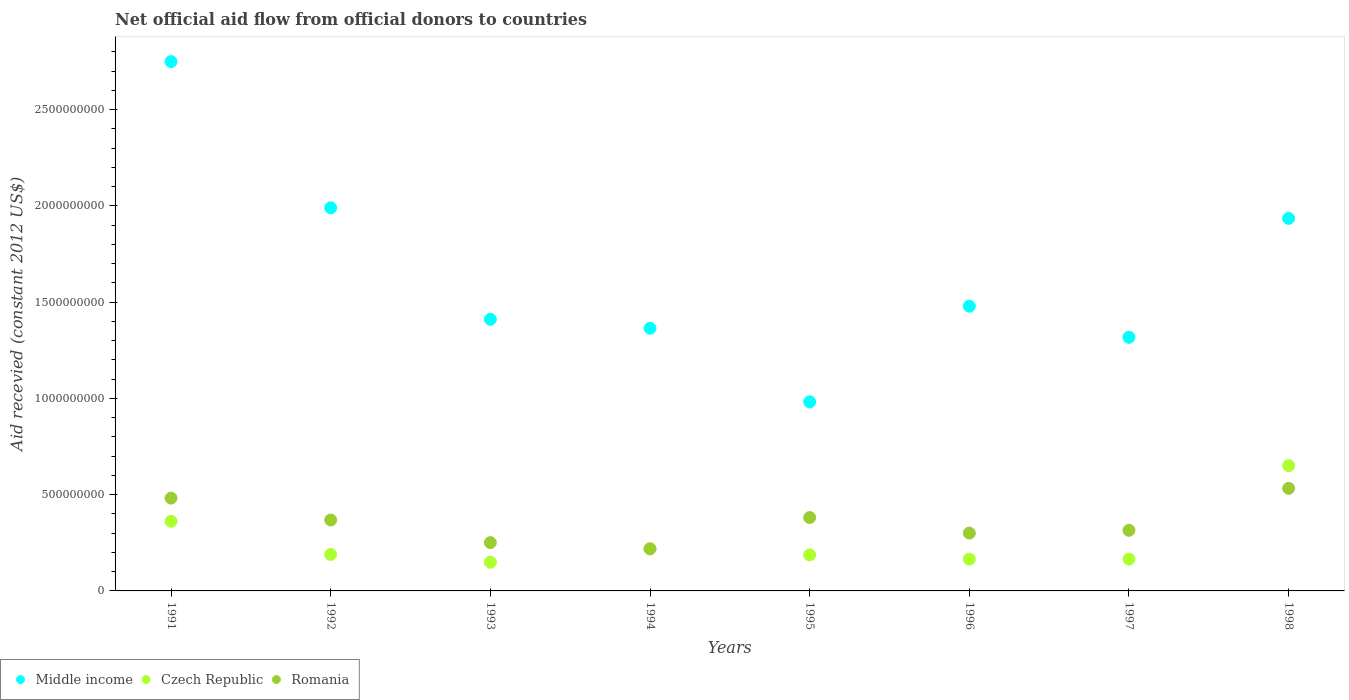How many different coloured dotlines are there?
Provide a short and direct response. 3. What is the total aid received in Czech Republic in 1995?
Provide a succinct answer. 1.87e+08. Across all years, what is the maximum total aid received in Czech Republic?
Provide a short and direct response. 6.50e+08. Across all years, what is the minimum total aid received in Middle income?
Keep it short and to the point. 9.82e+08. What is the total total aid received in Middle income in the graph?
Ensure brevity in your answer.  1.32e+1. What is the difference between the total aid received in Czech Republic in 1991 and that in 1995?
Give a very brief answer. 1.75e+08. What is the difference between the total aid received in Middle income in 1994 and the total aid received in Czech Republic in 1997?
Your answer should be compact. 1.20e+09. What is the average total aid received in Middle income per year?
Make the answer very short. 1.65e+09. In the year 1995, what is the difference between the total aid received in Czech Republic and total aid received in Romania?
Ensure brevity in your answer.  -1.94e+08. In how many years, is the total aid received in Romania greater than 2200000000 US$?
Keep it short and to the point. 0. What is the ratio of the total aid received in Middle income in 1992 to that in 1997?
Make the answer very short. 1.51. Is the difference between the total aid received in Czech Republic in 1994 and 1995 greater than the difference between the total aid received in Romania in 1994 and 1995?
Offer a terse response. Yes. What is the difference between the highest and the second highest total aid received in Romania?
Your answer should be very brief. 5.06e+07. What is the difference between the highest and the lowest total aid received in Middle income?
Offer a very short reply. 1.77e+09. In how many years, is the total aid received in Czech Republic greater than the average total aid received in Czech Republic taken over all years?
Make the answer very short. 2. Is the total aid received in Middle income strictly greater than the total aid received in Romania over the years?
Ensure brevity in your answer.  Yes. Is the total aid received in Czech Republic strictly less than the total aid received in Middle income over the years?
Offer a very short reply. Yes. How many dotlines are there?
Ensure brevity in your answer.  3. How many years are there in the graph?
Make the answer very short. 8. What is the difference between two consecutive major ticks on the Y-axis?
Your answer should be compact. 5.00e+08. Are the values on the major ticks of Y-axis written in scientific E-notation?
Provide a short and direct response. No. Does the graph contain any zero values?
Provide a short and direct response. No. Does the graph contain grids?
Your response must be concise. No. Where does the legend appear in the graph?
Give a very brief answer. Bottom left. How many legend labels are there?
Your answer should be very brief. 3. What is the title of the graph?
Provide a short and direct response. Net official aid flow from official donors to countries. What is the label or title of the X-axis?
Your response must be concise. Years. What is the label or title of the Y-axis?
Your response must be concise. Aid recevied (constant 2012 US$). What is the Aid recevied (constant 2012 US$) in Middle income in 1991?
Your response must be concise. 2.75e+09. What is the Aid recevied (constant 2012 US$) of Czech Republic in 1991?
Provide a short and direct response. 3.62e+08. What is the Aid recevied (constant 2012 US$) of Romania in 1991?
Ensure brevity in your answer.  4.82e+08. What is the Aid recevied (constant 2012 US$) in Middle income in 1992?
Make the answer very short. 1.99e+09. What is the Aid recevied (constant 2012 US$) in Czech Republic in 1992?
Give a very brief answer. 1.89e+08. What is the Aid recevied (constant 2012 US$) of Romania in 1992?
Your answer should be compact. 3.68e+08. What is the Aid recevied (constant 2012 US$) of Middle income in 1993?
Your answer should be compact. 1.41e+09. What is the Aid recevied (constant 2012 US$) in Czech Republic in 1993?
Keep it short and to the point. 1.49e+08. What is the Aid recevied (constant 2012 US$) of Romania in 1993?
Provide a succinct answer. 2.51e+08. What is the Aid recevied (constant 2012 US$) in Middle income in 1994?
Provide a short and direct response. 1.36e+09. What is the Aid recevied (constant 2012 US$) of Czech Republic in 1994?
Provide a succinct answer. 2.19e+08. What is the Aid recevied (constant 2012 US$) in Romania in 1994?
Give a very brief answer. 2.19e+08. What is the Aid recevied (constant 2012 US$) of Middle income in 1995?
Your answer should be compact. 9.82e+08. What is the Aid recevied (constant 2012 US$) of Czech Republic in 1995?
Offer a very short reply. 1.87e+08. What is the Aid recevied (constant 2012 US$) in Romania in 1995?
Offer a terse response. 3.81e+08. What is the Aid recevied (constant 2012 US$) of Middle income in 1996?
Provide a short and direct response. 1.48e+09. What is the Aid recevied (constant 2012 US$) in Czech Republic in 1996?
Give a very brief answer. 1.65e+08. What is the Aid recevied (constant 2012 US$) of Romania in 1996?
Give a very brief answer. 3.00e+08. What is the Aid recevied (constant 2012 US$) in Middle income in 1997?
Your answer should be very brief. 1.32e+09. What is the Aid recevied (constant 2012 US$) of Czech Republic in 1997?
Offer a very short reply. 1.65e+08. What is the Aid recevied (constant 2012 US$) in Romania in 1997?
Your answer should be compact. 3.15e+08. What is the Aid recevied (constant 2012 US$) in Middle income in 1998?
Offer a terse response. 1.93e+09. What is the Aid recevied (constant 2012 US$) of Czech Republic in 1998?
Your response must be concise. 6.50e+08. What is the Aid recevied (constant 2012 US$) of Romania in 1998?
Give a very brief answer. 5.33e+08. Across all years, what is the maximum Aid recevied (constant 2012 US$) in Middle income?
Give a very brief answer. 2.75e+09. Across all years, what is the maximum Aid recevied (constant 2012 US$) in Czech Republic?
Offer a very short reply. 6.50e+08. Across all years, what is the maximum Aid recevied (constant 2012 US$) in Romania?
Provide a succinct answer. 5.33e+08. Across all years, what is the minimum Aid recevied (constant 2012 US$) of Middle income?
Offer a terse response. 9.82e+08. Across all years, what is the minimum Aid recevied (constant 2012 US$) in Czech Republic?
Your answer should be very brief. 1.49e+08. Across all years, what is the minimum Aid recevied (constant 2012 US$) in Romania?
Make the answer very short. 2.19e+08. What is the total Aid recevied (constant 2012 US$) of Middle income in the graph?
Keep it short and to the point. 1.32e+1. What is the total Aid recevied (constant 2012 US$) of Czech Republic in the graph?
Offer a terse response. 2.09e+09. What is the total Aid recevied (constant 2012 US$) of Romania in the graph?
Make the answer very short. 2.85e+09. What is the difference between the Aid recevied (constant 2012 US$) of Middle income in 1991 and that in 1992?
Offer a very short reply. 7.59e+08. What is the difference between the Aid recevied (constant 2012 US$) in Czech Republic in 1991 and that in 1992?
Offer a very short reply. 1.72e+08. What is the difference between the Aid recevied (constant 2012 US$) in Romania in 1991 and that in 1992?
Provide a succinct answer. 1.14e+08. What is the difference between the Aid recevied (constant 2012 US$) in Middle income in 1991 and that in 1993?
Provide a succinct answer. 1.34e+09. What is the difference between the Aid recevied (constant 2012 US$) in Czech Republic in 1991 and that in 1993?
Offer a very short reply. 2.13e+08. What is the difference between the Aid recevied (constant 2012 US$) in Romania in 1991 and that in 1993?
Offer a terse response. 2.31e+08. What is the difference between the Aid recevied (constant 2012 US$) in Middle income in 1991 and that in 1994?
Keep it short and to the point. 1.39e+09. What is the difference between the Aid recevied (constant 2012 US$) of Czech Republic in 1991 and that in 1994?
Offer a terse response. 1.43e+08. What is the difference between the Aid recevied (constant 2012 US$) in Romania in 1991 and that in 1994?
Provide a succinct answer. 2.64e+08. What is the difference between the Aid recevied (constant 2012 US$) of Middle income in 1991 and that in 1995?
Your answer should be compact. 1.77e+09. What is the difference between the Aid recevied (constant 2012 US$) of Czech Republic in 1991 and that in 1995?
Offer a very short reply. 1.75e+08. What is the difference between the Aid recevied (constant 2012 US$) in Romania in 1991 and that in 1995?
Provide a succinct answer. 1.01e+08. What is the difference between the Aid recevied (constant 2012 US$) in Middle income in 1991 and that in 1996?
Offer a very short reply. 1.27e+09. What is the difference between the Aid recevied (constant 2012 US$) of Czech Republic in 1991 and that in 1996?
Your answer should be very brief. 1.96e+08. What is the difference between the Aid recevied (constant 2012 US$) of Romania in 1991 and that in 1996?
Keep it short and to the point. 1.82e+08. What is the difference between the Aid recevied (constant 2012 US$) of Middle income in 1991 and that in 1997?
Give a very brief answer. 1.43e+09. What is the difference between the Aid recevied (constant 2012 US$) in Czech Republic in 1991 and that in 1997?
Give a very brief answer. 1.97e+08. What is the difference between the Aid recevied (constant 2012 US$) in Romania in 1991 and that in 1997?
Your response must be concise. 1.67e+08. What is the difference between the Aid recevied (constant 2012 US$) of Middle income in 1991 and that in 1998?
Provide a succinct answer. 8.14e+08. What is the difference between the Aid recevied (constant 2012 US$) of Czech Republic in 1991 and that in 1998?
Offer a very short reply. -2.89e+08. What is the difference between the Aid recevied (constant 2012 US$) of Romania in 1991 and that in 1998?
Your answer should be very brief. -5.06e+07. What is the difference between the Aid recevied (constant 2012 US$) of Middle income in 1992 and that in 1993?
Provide a short and direct response. 5.79e+08. What is the difference between the Aid recevied (constant 2012 US$) in Czech Republic in 1992 and that in 1993?
Offer a very short reply. 4.06e+07. What is the difference between the Aid recevied (constant 2012 US$) of Romania in 1992 and that in 1993?
Your answer should be very brief. 1.18e+08. What is the difference between the Aid recevied (constant 2012 US$) in Middle income in 1992 and that in 1994?
Make the answer very short. 6.26e+08. What is the difference between the Aid recevied (constant 2012 US$) in Czech Republic in 1992 and that in 1994?
Keep it short and to the point. -2.92e+07. What is the difference between the Aid recevied (constant 2012 US$) of Romania in 1992 and that in 1994?
Provide a short and direct response. 1.50e+08. What is the difference between the Aid recevied (constant 2012 US$) in Middle income in 1992 and that in 1995?
Provide a succinct answer. 1.01e+09. What is the difference between the Aid recevied (constant 2012 US$) in Czech Republic in 1992 and that in 1995?
Your answer should be compact. 2.42e+06. What is the difference between the Aid recevied (constant 2012 US$) of Romania in 1992 and that in 1995?
Your response must be concise. -1.27e+07. What is the difference between the Aid recevied (constant 2012 US$) of Middle income in 1992 and that in 1996?
Ensure brevity in your answer.  5.11e+08. What is the difference between the Aid recevied (constant 2012 US$) in Czech Republic in 1992 and that in 1996?
Ensure brevity in your answer.  2.42e+07. What is the difference between the Aid recevied (constant 2012 US$) in Romania in 1992 and that in 1996?
Ensure brevity in your answer.  6.80e+07. What is the difference between the Aid recevied (constant 2012 US$) in Middle income in 1992 and that in 1997?
Keep it short and to the point. 6.73e+08. What is the difference between the Aid recevied (constant 2012 US$) in Czech Republic in 1992 and that in 1997?
Your response must be concise. 2.43e+07. What is the difference between the Aid recevied (constant 2012 US$) in Romania in 1992 and that in 1997?
Keep it short and to the point. 5.36e+07. What is the difference between the Aid recevied (constant 2012 US$) in Middle income in 1992 and that in 1998?
Give a very brief answer. 5.51e+07. What is the difference between the Aid recevied (constant 2012 US$) in Czech Republic in 1992 and that in 1998?
Offer a very short reply. -4.61e+08. What is the difference between the Aid recevied (constant 2012 US$) in Romania in 1992 and that in 1998?
Provide a short and direct response. -1.64e+08. What is the difference between the Aid recevied (constant 2012 US$) of Middle income in 1993 and that in 1994?
Provide a succinct answer. 4.66e+07. What is the difference between the Aid recevied (constant 2012 US$) of Czech Republic in 1993 and that in 1994?
Your answer should be very brief. -6.97e+07. What is the difference between the Aid recevied (constant 2012 US$) in Romania in 1993 and that in 1994?
Your response must be concise. 3.24e+07. What is the difference between the Aid recevied (constant 2012 US$) in Middle income in 1993 and that in 1995?
Provide a short and direct response. 4.29e+08. What is the difference between the Aid recevied (constant 2012 US$) in Czech Republic in 1993 and that in 1995?
Offer a very short reply. -3.82e+07. What is the difference between the Aid recevied (constant 2012 US$) in Romania in 1993 and that in 1995?
Provide a short and direct response. -1.30e+08. What is the difference between the Aid recevied (constant 2012 US$) in Middle income in 1993 and that in 1996?
Ensure brevity in your answer.  -6.84e+07. What is the difference between the Aid recevied (constant 2012 US$) in Czech Republic in 1993 and that in 1996?
Your answer should be very brief. -1.64e+07. What is the difference between the Aid recevied (constant 2012 US$) in Romania in 1993 and that in 1996?
Give a very brief answer. -4.95e+07. What is the difference between the Aid recevied (constant 2012 US$) in Middle income in 1993 and that in 1997?
Your answer should be very brief. 9.34e+07. What is the difference between the Aid recevied (constant 2012 US$) in Czech Republic in 1993 and that in 1997?
Offer a very short reply. -1.63e+07. What is the difference between the Aid recevied (constant 2012 US$) in Romania in 1993 and that in 1997?
Offer a terse response. -6.39e+07. What is the difference between the Aid recevied (constant 2012 US$) in Middle income in 1993 and that in 1998?
Your response must be concise. -5.24e+08. What is the difference between the Aid recevied (constant 2012 US$) in Czech Republic in 1993 and that in 1998?
Give a very brief answer. -5.02e+08. What is the difference between the Aid recevied (constant 2012 US$) of Romania in 1993 and that in 1998?
Your answer should be compact. -2.82e+08. What is the difference between the Aid recevied (constant 2012 US$) of Middle income in 1994 and that in 1995?
Ensure brevity in your answer.  3.82e+08. What is the difference between the Aid recevied (constant 2012 US$) of Czech Republic in 1994 and that in 1995?
Keep it short and to the point. 3.16e+07. What is the difference between the Aid recevied (constant 2012 US$) of Romania in 1994 and that in 1995?
Offer a terse response. -1.63e+08. What is the difference between the Aid recevied (constant 2012 US$) in Middle income in 1994 and that in 1996?
Offer a terse response. -1.15e+08. What is the difference between the Aid recevied (constant 2012 US$) of Czech Republic in 1994 and that in 1996?
Offer a terse response. 5.34e+07. What is the difference between the Aid recevied (constant 2012 US$) of Romania in 1994 and that in 1996?
Make the answer very short. -8.19e+07. What is the difference between the Aid recevied (constant 2012 US$) in Middle income in 1994 and that in 1997?
Your response must be concise. 4.68e+07. What is the difference between the Aid recevied (constant 2012 US$) of Czech Republic in 1994 and that in 1997?
Your answer should be very brief. 5.34e+07. What is the difference between the Aid recevied (constant 2012 US$) in Romania in 1994 and that in 1997?
Ensure brevity in your answer.  -9.63e+07. What is the difference between the Aid recevied (constant 2012 US$) of Middle income in 1994 and that in 1998?
Offer a terse response. -5.71e+08. What is the difference between the Aid recevied (constant 2012 US$) in Czech Republic in 1994 and that in 1998?
Offer a terse response. -4.32e+08. What is the difference between the Aid recevied (constant 2012 US$) of Romania in 1994 and that in 1998?
Your answer should be compact. -3.14e+08. What is the difference between the Aid recevied (constant 2012 US$) in Middle income in 1995 and that in 1996?
Offer a very short reply. -4.97e+08. What is the difference between the Aid recevied (constant 2012 US$) in Czech Republic in 1995 and that in 1996?
Your answer should be very brief. 2.18e+07. What is the difference between the Aid recevied (constant 2012 US$) in Romania in 1995 and that in 1996?
Offer a very short reply. 8.07e+07. What is the difference between the Aid recevied (constant 2012 US$) in Middle income in 1995 and that in 1997?
Your answer should be very brief. -3.35e+08. What is the difference between the Aid recevied (constant 2012 US$) in Czech Republic in 1995 and that in 1997?
Your response must be concise. 2.19e+07. What is the difference between the Aid recevied (constant 2012 US$) in Romania in 1995 and that in 1997?
Offer a very short reply. 6.63e+07. What is the difference between the Aid recevied (constant 2012 US$) of Middle income in 1995 and that in 1998?
Offer a terse response. -9.53e+08. What is the difference between the Aid recevied (constant 2012 US$) of Czech Republic in 1995 and that in 1998?
Your answer should be compact. -4.63e+08. What is the difference between the Aid recevied (constant 2012 US$) in Romania in 1995 and that in 1998?
Make the answer very short. -1.52e+08. What is the difference between the Aid recevied (constant 2012 US$) in Middle income in 1996 and that in 1997?
Your response must be concise. 1.62e+08. What is the difference between the Aid recevied (constant 2012 US$) of Czech Republic in 1996 and that in 1997?
Offer a terse response. 1.00e+05. What is the difference between the Aid recevied (constant 2012 US$) of Romania in 1996 and that in 1997?
Ensure brevity in your answer.  -1.44e+07. What is the difference between the Aid recevied (constant 2012 US$) of Middle income in 1996 and that in 1998?
Your answer should be very brief. -4.56e+08. What is the difference between the Aid recevied (constant 2012 US$) in Czech Republic in 1996 and that in 1998?
Your answer should be very brief. -4.85e+08. What is the difference between the Aid recevied (constant 2012 US$) in Romania in 1996 and that in 1998?
Provide a short and direct response. -2.32e+08. What is the difference between the Aid recevied (constant 2012 US$) of Middle income in 1997 and that in 1998?
Give a very brief answer. -6.18e+08. What is the difference between the Aid recevied (constant 2012 US$) in Czech Republic in 1997 and that in 1998?
Offer a very short reply. -4.85e+08. What is the difference between the Aid recevied (constant 2012 US$) in Romania in 1997 and that in 1998?
Provide a succinct answer. -2.18e+08. What is the difference between the Aid recevied (constant 2012 US$) of Middle income in 1991 and the Aid recevied (constant 2012 US$) of Czech Republic in 1992?
Provide a succinct answer. 2.56e+09. What is the difference between the Aid recevied (constant 2012 US$) of Middle income in 1991 and the Aid recevied (constant 2012 US$) of Romania in 1992?
Your answer should be compact. 2.38e+09. What is the difference between the Aid recevied (constant 2012 US$) of Czech Republic in 1991 and the Aid recevied (constant 2012 US$) of Romania in 1992?
Your answer should be very brief. -6.78e+06. What is the difference between the Aid recevied (constant 2012 US$) in Middle income in 1991 and the Aid recevied (constant 2012 US$) in Czech Republic in 1993?
Offer a very short reply. 2.60e+09. What is the difference between the Aid recevied (constant 2012 US$) of Middle income in 1991 and the Aid recevied (constant 2012 US$) of Romania in 1993?
Provide a short and direct response. 2.50e+09. What is the difference between the Aid recevied (constant 2012 US$) in Czech Republic in 1991 and the Aid recevied (constant 2012 US$) in Romania in 1993?
Your answer should be compact. 1.11e+08. What is the difference between the Aid recevied (constant 2012 US$) of Middle income in 1991 and the Aid recevied (constant 2012 US$) of Czech Republic in 1994?
Provide a succinct answer. 2.53e+09. What is the difference between the Aid recevied (constant 2012 US$) of Middle income in 1991 and the Aid recevied (constant 2012 US$) of Romania in 1994?
Ensure brevity in your answer.  2.53e+09. What is the difference between the Aid recevied (constant 2012 US$) of Czech Republic in 1991 and the Aid recevied (constant 2012 US$) of Romania in 1994?
Offer a terse response. 1.43e+08. What is the difference between the Aid recevied (constant 2012 US$) of Middle income in 1991 and the Aid recevied (constant 2012 US$) of Czech Republic in 1995?
Your response must be concise. 2.56e+09. What is the difference between the Aid recevied (constant 2012 US$) in Middle income in 1991 and the Aid recevied (constant 2012 US$) in Romania in 1995?
Offer a very short reply. 2.37e+09. What is the difference between the Aid recevied (constant 2012 US$) of Czech Republic in 1991 and the Aid recevied (constant 2012 US$) of Romania in 1995?
Provide a short and direct response. -1.95e+07. What is the difference between the Aid recevied (constant 2012 US$) of Middle income in 1991 and the Aid recevied (constant 2012 US$) of Czech Republic in 1996?
Give a very brief answer. 2.58e+09. What is the difference between the Aid recevied (constant 2012 US$) of Middle income in 1991 and the Aid recevied (constant 2012 US$) of Romania in 1996?
Offer a terse response. 2.45e+09. What is the difference between the Aid recevied (constant 2012 US$) of Czech Republic in 1991 and the Aid recevied (constant 2012 US$) of Romania in 1996?
Keep it short and to the point. 6.12e+07. What is the difference between the Aid recevied (constant 2012 US$) in Middle income in 1991 and the Aid recevied (constant 2012 US$) in Czech Republic in 1997?
Provide a short and direct response. 2.58e+09. What is the difference between the Aid recevied (constant 2012 US$) in Middle income in 1991 and the Aid recevied (constant 2012 US$) in Romania in 1997?
Ensure brevity in your answer.  2.43e+09. What is the difference between the Aid recevied (constant 2012 US$) in Czech Republic in 1991 and the Aid recevied (constant 2012 US$) in Romania in 1997?
Provide a succinct answer. 4.68e+07. What is the difference between the Aid recevied (constant 2012 US$) in Middle income in 1991 and the Aid recevied (constant 2012 US$) in Czech Republic in 1998?
Your answer should be compact. 2.10e+09. What is the difference between the Aid recevied (constant 2012 US$) in Middle income in 1991 and the Aid recevied (constant 2012 US$) in Romania in 1998?
Your response must be concise. 2.22e+09. What is the difference between the Aid recevied (constant 2012 US$) in Czech Republic in 1991 and the Aid recevied (constant 2012 US$) in Romania in 1998?
Ensure brevity in your answer.  -1.71e+08. What is the difference between the Aid recevied (constant 2012 US$) of Middle income in 1992 and the Aid recevied (constant 2012 US$) of Czech Republic in 1993?
Offer a very short reply. 1.84e+09. What is the difference between the Aid recevied (constant 2012 US$) of Middle income in 1992 and the Aid recevied (constant 2012 US$) of Romania in 1993?
Keep it short and to the point. 1.74e+09. What is the difference between the Aid recevied (constant 2012 US$) of Czech Republic in 1992 and the Aid recevied (constant 2012 US$) of Romania in 1993?
Give a very brief answer. -6.15e+07. What is the difference between the Aid recevied (constant 2012 US$) of Middle income in 1992 and the Aid recevied (constant 2012 US$) of Czech Republic in 1994?
Keep it short and to the point. 1.77e+09. What is the difference between the Aid recevied (constant 2012 US$) of Middle income in 1992 and the Aid recevied (constant 2012 US$) of Romania in 1994?
Ensure brevity in your answer.  1.77e+09. What is the difference between the Aid recevied (constant 2012 US$) of Czech Republic in 1992 and the Aid recevied (constant 2012 US$) of Romania in 1994?
Your answer should be very brief. -2.92e+07. What is the difference between the Aid recevied (constant 2012 US$) of Middle income in 1992 and the Aid recevied (constant 2012 US$) of Czech Republic in 1995?
Your answer should be very brief. 1.80e+09. What is the difference between the Aid recevied (constant 2012 US$) in Middle income in 1992 and the Aid recevied (constant 2012 US$) in Romania in 1995?
Provide a succinct answer. 1.61e+09. What is the difference between the Aid recevied (constant 2012 US$) of Czech Republic in 1992 and the Aid recevied (constant 2012 US$) of Romania in 1995?
Your answer should be very brief. -1.92e+08. What is the difference between the Aid recevied (constant 2012 US$) in Middle income in 1992 and the Aid recevied (constant 2012 US$) in Czech Republic in 1996?
Provide a succinct answer. 1.82e+09. What is the difference between the Aid recevied (constant 2012 US$) in Middle income in 1992 and the Aid recevied (constant 2012 US$) in Romania in 1996?
Your answer should be compact. 1.69e+09. What is the difference between the Aid recevied (constant 2012 US$) of Czech Republic in 1992 and the Aid recevied (constant 2012 US$) of Romania in 1996?
Your answer should be compact. -1.11e+08. What is the difference between the Aid recevied (constant 2012 US$) of Middle income in 1992 and the Aid recevied (constant 2012 US$) of Czech Republic in 1997?
Your response must be concise. 1.82e+09. What is the difference between the Aid recevied (constant 2012 US$) of Middle income in 1992 and the Aid recevied (constant 2012 US$) of Romania in 1997?
Offer a very short reply. 1.68e+09. What is the difference between the Aid recevied (constant 2012 US$) of Czech Republic in 1992 and the Aid recevied (constant 2012 US$) of Romania in 1997?
Your answer should be compact. -1.25e+08. What is the difference between the Aid recevied (constant 2012 US$) of Middle income in 1992 and the Aid recevied (constant 2012 US$) of Czech Republic in 1998?
Keep it short and to the point. 1.34e+09. What is the difference between the Aid recevied (constant 2012 US$) of Middle income in 1992 and the Aid recevied (constant 2012 US$) of Romania in 1998?
Your answer should be compact. 1.46e+09. What is the difference between the Aid recevied (constant 2012 US$) in Czech Republic in 1992 and the Aid recevied (constant 2012 US$) in Romania in 1998?
Ensure brevity in your answer.  -3.43e+08. What is the difference between the Aid recevied (constant 2012 US$) of Middle income in 1993 and the Aid recevied (constant 2012 US$) of Czech Republic in 1994?
Offer a very short reply. 1.19e+09. What is the difference between the Aid recevied (constant 2012 US$) in Middle income in 1993 and the Aid recevied (constant 2012 US$) in Romania in 1994?
Make the answer very short. 1.19e+09. What is the difference between the Aid recevied (constant 2012 US$) of Czech Republic in 1993 and the Aid recevied (constant 2012 US$) of Romania in 1994?
Offer a terse response. -6.97e+07. What is the difference between the Aid recevied (constant 2012 US$) in Middle income in 1993 and the Aid recevied (constant 2012 US$) in Czech Republic in 1995?
Provide a short and direct response. 1.22e+09. What is the difference between the Aid recevied (constant 2012 US$) of Middle income in 1993 and the Aid recevied (constant 2012 US$) of Romania in 1995?
Ensure brevity in your answer.  1.03e+09. What is the difference between the Aid recevied (constant 2012 US$) of Czech Republic in 1993 and the Aid recevied (constant 2012 US$) of Romania in 1995?
Provide a succinct answer. -2.32e+08. What is the difference between the Aid recevied (constant 2012 US$) in Middle income in 1993 and the Aid recevied (constant 2012 US$) in Czech Republic in 1996?
Your response must be concise. 1.25e+09. What is the difference between the Aid recevied (constant 2012 US$) in Middle income in 1993 and the Aid recevied (constant 2012 US$) in Romania in 1996?
Ensure brevity in your answer.  1.11e+09. What is the difference between the Aid recevied (constant 2012 US$) of Czech Republic in 1993 and the Aid recevied (constant 2012 US$) of Romania in 1996?
Ensure brevity in your answer.  -1.52e+08. What is the difference between the Aid recevied (constant 2012 US$) of Middle income in 1993 and the Aid recevied (constant 2012 US$) of Czech Republic in 1997?
Your answer should be compact. 1.25e+09. What is the difference between the Aid recevied (constant 2012 US$) in Middle income in 1993 and the Aid recevied (constant 2012 US$) in Romania in 1997?
Keep it short and to the point. 1.10e+09. What is the difference between the Aid recevied (constant 2012 US$) of Czech Republic in 1993 and the Aid recevied (constant 2012 US$) of Romania in 1997?
Give a very brief answer. -1.66e+08. What is the difference between the Aid recevied (constant 2012 US$) in Middle income in 1993 and the Aid recevied (constant 2012 US$) in Czech Republic in 1998?
Your answer should be very brief. 7.60e+08. What is the difference between the Aid recevied (constant 2012 US$) in Middle income in 1993 and the Aid recevied (constant 2012 US$) in Romania in 1998?
Keep it short and to the point. 8.78e+08. What is the difference between the Aid recevied (constant 2012 US$) of Czech Republic in 1993 and the Aid recevied (constant 2012 US$) of Romania in 1998?
Ensure brevity in your answer.  -3.84e+08. What is the difference between the Aid recevied (constant 2012 US$) of Middle income in 1994 and the Aid recevied (constant 2012 US$) of Czech Republic in 1995?
Offer a terse response. 1.18e+09. What is the difference between the Aid recevied (constant 2012 US$) in Middle income in 1994 and the Aid recevied (constant 2012 US$) in Romania in 1995?
Your answer should be compact. 9.83e+08. What is the difference between the Aid recevied (constant 2012 US$) in Czech Republic in 1994 and the Aid recevied (constant 2012 US$) in Romania in 1995?
Your answer should be very brief. -1.63e+08. What is the difference between the Aid recevied (constant 2012 US$) in Middle income in 1994 and the Aid recevied (constant 2012 US$) in Czech Republic in 1996?
Make the answer very short. 1.20e+09. What is the difference between the Aid recevied (constant 2012 US$) of Middle income in 1994 and the Aid recevied (constant 2012 US$) of Romania in 1996?
Your answer should be very brief. 1.06e+09. What is the difference between the Aid recevied (constant 2012 US$) in Czech Republic in 1994 and the Aid recevied (constant 2012 US$) in Romania in 1996?
Provide a succinct answer. -8.19e+07. What is the difference between the Aid recevied (constant 2012 US$) of Middle income in 1994 and the Aid recevied (constant 2012 US$) of Czech Republic in 1997?
Offer a terse response. 1.20e+09. What is the difference between the Aid recevied (constant 2012 US$) in Middle income in 1994 and the Aid recevied (constant 2012 US$) in Romania in 1997?
Offer a very short reply. 1.05e+09. What is the difference between the Aid recevied (constant 2012 US$) in Czech Republic in 1994 and the Aid recevied (constant 2012 US$) in Romania in 1997?
Your response must be concise. -9.63e+07. What is the difference between the Aid recevied (constant 2012 US$) in Middle income in 1994 and the Aid recevied (constant 2012 US$) in Czech Republic in 1998?
Offer a very short reply. 7.14e+08. What is the difference between the Aid recevied (constant 2012 US$) in Middle income in 1994 and the Aid recevied (constant 2012 US$) in Romania in 1998?
Give a very brief answer. 8.31e+08. What is the difference between the Aid recevied (constant 2012 US$) of Czech Republic in 1994 and the Aid recevied (constant 2012 US$) of Romania in 1998?
Your answer should be compact. -3.14e+08. What is the difference between the Aid recevied (constant 2012 US$) of Middle income in 1995 and the Aid recevied (constant 2012 US$) of Czech Republic in 1996?
Offer a terse response. 8.17e+08. What is the difference between the Aid recevied (constant 2012 US$) in Middle income in 1995 and the Aid recevied (constant 2012 US$) in Romania in 1996?
Your answer should be compact. 6.81e+08. What is the difference between the Aid recevied (constant 2012 US$) of Czech Republic in 1995 and the Aid recevied (constant 2012 US$) of Romania in 1996?
Your answer should be compact. -1.13e+08. What is the difference between the Aid recevied (constant 2012 US$) of Middle income in 1995 and the Aid recevied (constant 2012 US$) of Czech Republic in 1997?
Offer a terse response. 8.17e+08. What is the difference between the Aid recevied (constant 2012 US$) of Middle income in 1995 and the Aid recevied (constant 2012 US$) of Romania in 1997?
Ensure brevity in your answer.  6.67e+08. What is the difference between the Aid recevied (constant 2012 US$) of Czech Republic in 1995 and the Aid recevied (constant 2012 US$) of Romania in 1997?
Offer a terse response. -1.28e+08. What is the difference between the Aid recevied (constant 2012 US$) in Middle income in 1995 and the Aid recevied (constant 2012 US$) in Czech Republic in 1998?
Make the answer very short. 3.32e+08. What is the difference between the Aid recevied (constant 2012 US$) in Middle income in 1995 and the Aid recevied (constant 2012 US$) in Romania in 1998?
Give a very brief answer. 4.49e+08. What is the difference between the Aid recevied (constant 2012 US$) of Czech Republic in 1995 and the Aid recevied (constant 2012 US$) of Romania in 1998?
Give a very brief answer. -3.46e+08. What is the difference between the Aid recevied (constant 2012 US$) in Middle income in 1996 and the Aid recevied (constant 2012 US$) in Czech Republic in 1997?
Make the answer very short. 1.31e+09. What is the difference between the Aid recevied (constant 2012 US$) of Middle income in 1996 and the Aid recevied (constant 2012 US$) of Romania in 1997?
Your response must be concise. 1.16e+09. What is the difference between the Aid recevied (constant 2012 US$) in Czech Republic in 1996 and the Aid recevied (constant 2012 US$) in Romania in 1997?
Give a very brief answer. -1.50e+08. What is the difference between the Aid recevied (constant 2012 US$) in Middle income in 1996 and the Aid recevied (constant 2012 US$) in Czech Republic in 1998?
Give a very brief answer. 8.28e+08. What is the difference between the Aid recevied (constant 2012 US$) in Middle income in 1996 and the Aid recevied (constant 2012 US$) in Romania in 1998?
Offer a very short reply. 9.46e+08. What is the difference between the Aid recevied (constant 2012 US$) of Czech Republic in 1996 and the Aid recevied (constant 2012 US$) of Romania in 1998?
Offer a very short reply. -3.67e+08. What is the difference between the Aid recevied (constant 2012 US$) in Middle income in 1997 and the Aid recevied (constant 2012 US$) in Czech Republic in 1998?
Provide a short and direct response. 6.67e+08. What is the difference between the Aid recevied (constant 2012 US$) of Middle income in 1997 and the Aid recevied (constant 2012 US$) of Romania in 1998?
Your answer should be very brief. 7.84e+08. What is the difference between the Aid recevied (constant 2012 US$) of Czech Republic in 1997 and the Aid recevied (constant 2012 US$) of Romania in 1998?
Your answer should be compact. -3.68e+08. What is the average Aid recevied (constant 2012 US$) in Middle income per year?
Ensure brevity in your answer.  1.65e+09. What is the average Aid recevied (constant 2012 US$) in Czech Republic per year?
Make the answer very short. 2.61e+08. What is the average Aid recevied (constant 2012 US$) in Romania per year?
Ensure brevity in your answer.  3.56e+08. In the year 1991, what is the difference between the Aid recevied (constant 2012 US$) in Middle income and Aid recevied (constant 2012 US$) in Czech Republic?
Provide a short and direct response. 2.39e+09. In the year 1991, what is the difference between the Aid recevied (constant 2012 US$) in Middle income and Aid recevied (constant 2012 US$) in Romania?
Your answer should be compact. 2.27e+09. In the year 1991, what is the difference between the Aid recevied (constant 2012 US$) in Czech Republic and Aid recevied (constant 2012 US$) in Romania?
Offer a terse response. -1.20e+08. In the year 1992, what is the difference between the Aid recevied (constant 2012 US$) of Middle income and Aid recevied (constant 2012 US$) of Czech Republic?
Offer a terse response. 1.80e+09. In the year 1992, what is the difference between the Aid recevied (constant 2012 US$) in Middle income and Aid recevied (constant 2012 US$) in Romania?
Offer a terse response. 1.62e+09. In the year 1992, what is the difference between the Aid recevied (constant 2012 US$) in Czech Republic and Aid recevied (constant 2012 US$) in Romania?
Make the answer very short. -1.79e+08. In the year 1993, what is the difference between the Aid recevied (constant 2012 US$) of Middle income and Aid recevied (constant 2012 US$) of Czech Republic?
Your answer should be very brief. 1.26e+09. In the year 1993, what is the difference between the Aid recevied (constant 2012 US$) in Middle income and Aid recevied (constant 2012 US$) in Romania?
Ensure brevity in your answer.  1.16e+09. In the year 1993, what is the difference between the Aid recevied (constant 2012 US$) in Czech Republic and Aid recevied (constant 2012 US$) in Romania?
Ensure brevity in your answer.  -1.02e+08. In the year 1994, what is the difference between the Aid recevied (constant 2012 US$) of Middle income and Aid recevied (constant 2012 US$) of Czech Republic?
Provide a short and direct response. 1.15e+09. In the year 1994, what is the difference between the Aid recevied (constant 2012 US$) of Middle income and Aid recevied (constant 2012 US$) of Romania?
Keep it short and to the point. 1.15e+09. In the year 1995, what is the difference between the Aid recevied (constant 2012 US$) of Middle income and Aid recevied (constant 2012 US$) of Czech Republic?
Provide a succinct answer. 7.95e+08. In the year 1995, what is the difference between the Aid recevied (constant 2012 US$) of Middle income and Aid recevied (constant 2012 US$) of Romania?
Keep it short and to the point. 6.01e+08. In the year 1995, what is the difference between the Aid recevied (constant 2012 US$) of Czech Republic and Aid recevied (constant 2012 US$) of Romania?
Your answer should be very brief. -1.94e+08. In the year 1996, what is the difference between the Aid recevied (constant 2012 US$) in Middle income and Aid recevied (constant 2012 US$) in Czech Republic?
Your answer should be very brief. 1.31e+09. In the year 1996, what is the difference between the Aid recevied (constant 2012 US$) in Middle income and Aid recevied (constant 2012 US$) in Romania?
Make the answer very short. 1.18e+09. In the year 1996, what is the difference between the Aid recevied (constant 2012 US$) in Czech Republic and Aid recevied (constant 2012 US$) in Romania?
Keep it short and to the point. -1.35e+08. In the year 1997, what is the difference between the Aid recevied (constant 2012 US$) of Middle income and Aid recevied (constant 2012 US$) of Czech Republic?
Provide a succinct answer. 1.15e+09. In the year 1997, what is the difference between the Aid recevied (constant 2012 US$) of Middle income and Aid recevied (constant 2012 US$) of Romania?
Offer a terse response. 1.00e+09. In the year 1997, what is the difference between the Aid recevied (constant 2012 US$) of Czech Republic and Aid recevied (constant 2012 US$) of Romania?
Provide a succinct answer. -1.50e+08. In the year 1998, what is the difference between the Aid recevied (constant 2012 US$) of Middle income and Aid recevied (constant 2012 US$) of Czech Republic?
Give a very brief answer. 1.28e+09. In the year 1998, what is the difference between the Aid recevied (constant 2012 US$) in Middle income and Aid recevied (constant 2012 US$) in Romania?
Provide a succinct answer. 1.40e+09. In the year 1998, what is the difference between the Aid recevied (constant 2012 US$) of Czech Republic and Aid recevied (constant 2012 US$) of Romania?
Offer a very short reply. 1.18e+08. What is the ratio of the Aid recevied (constant 2012 US$) in Middle income in 1991 to that in 1992?
Your answer should be compact. 1.38. What is the ratio of the Aid recevied (constant 2012 US$) in Czech Republic in 1991 to that in 1992?
Provide a short and direct response. 1.91. What is the ratio of the Aid recevied (constant 2012 US$) of Romania in 1991 to that in 1992?
Give a very brief answer. 1.31. What is the ratio of the Aid recevied (constant 2012 US$) of Middle income in 1991 to that in 1993?
Your answer should be compact. 1.95. What is the ratio of the Aid recevied (constant 2012 US$) of Czech Republic in 1991 to that in 1993?
Provide a succinct answer. 2.43. What is the ratio of the Aid recevied (constant 2012 US$) of Romania in 1991 to that in 1993?
Provide a short and direct response. 1.92. What is the ratio of the Aid recevied (constant 2012 US$) in Middle income in 1991 to that in 1994?
Offer a terse response. 2.02. What is the ratio of the Aid recevied (constant 2012 US$) of Czech Republic in 1991 to that in 1994?
Offer a terse response. 1.65. What is the ratio of the Aid recevied (constant 2012 US$) of Romania in 1991 to that in 1994?
Offer a very short reply. 2.21. What is the ratio of the Aid recevied (constant 2012 US$) in Middle income in 1991 to that in 1995?
Provide a short and direct response. 2.8. What is the ratio of the Aid recevied (constant 2012 US$) of Czech Republic in 1991 to that in 1995?
Offer a very short reply. 1.93. What is the ratio of the Aid recevied (constant 2012 US$) of Romania in 1991 to that in 1995?
Offer a very short reply. 1.26. What is the ratio of the Aid recevied (constant 2012 US$) in Middle income in 1991 to that in 1996?
Make the answer very short. 1.86. What is the ratio of the Aid recevied (constant 2012 US$) of Czech Republic in 1991 to that in 1996?
Your answer should be very brief. 2.19. What is the ratio of the Aid recevied (constant 2012 US$) of Romania in 1991 to that in 1996?
Your answer should be compact. 1.6. What is the ratio of the Aid recevied (constant 2012 US$) of Middle income in 1991 to that in 1997?
Your answer should be very brief. 2.09. What is the ratio of the Aid recevied (constant 2012 US$) in Czech Republic in 1991 to that in 1997?
Make the answer very short. 2.19. What is the ratio of the Aid recevied (constant 2012 US$) in Romania in 1991 to that in 1997?
Give a very brief answer. 1.53. What is the ratio of the Aid recevied (constant 2012 US$) of Middle income in 1991 to that in 1998?
Give a very brief answer. 1.42. What is the ratio of the Aid recevied (constant 2012 US$) in Czech Republic in 1991 to that in 1998?
Provide a short and direct response. 0.56. What is the ratio of the Aid recevied (constant 2012 US$) of Romania in 1991 to that in 1998?
Your answer should be compact. 0.91. What is the ratio of the Aid recevied (constant 2012 US$) in Middle income in 1992 to that in 1993?
Provide a short and direct response. 1.41. What is the ratio of the Aid recevied (constant 2012 US$) in Czech Republic in 1992 to that in 1993?
Your answer should be compact. 1.27. What is the ratio of the Aid recevied (constant 2012 US$) in Romania in 1992 to that in 1993?
Your answer should be compact. 1.47. What is the ratio of the Aid recevied (constant 2012 US$) of Middle income in 1992 to that in 1994?
Give a very brief answer. 1.46. What is the ratio of the Aid recevied (constant 2012 US$) of Czech Republic in 1992 to that in 1994?
Make the answer very short. 0.87. What is the ratio of the Aid recevied (constant 2012 US$) of Romania in 1992 to that in 1994?
Make the answer very short. 1.69. What is the ratio of the Aid recevied (constant 2012 US$) in Middle income in 1992 to that in 1995?
Give a very brief answer. 2.03. What is the ratio of the Aid recevied (constant 2012 US$) in Czech Republic in 1992 to that in 1995?
Give a very brief answer. 1.01. What is the ratio of the Aid recevied (constant 2012 US$) of Romania in 1992 to that in 1995?
Make the answer very short. 0.97. What is the ratio of the Aid recevied (constant 2012 US$) of Middle income in 1992 to that in 1996?
Keep it short and to the point. 1.35. What is the ratio of the Aid recevied (constant 2012 US$) of Czech Republic in 1992 to that in 1996?
Offer a very short reply. 1.15. What is the ratio of the Aid recevied (constant 2012 US$) of Romania in 1992 to that in 1996?
Give a very brief answer. 1.23. What is the ratio of the Aid recevied (constant 2012 US$) in Middle income in 1992 to that in 1997?
Offer a terse response. 1.51. What is the ratio of the Aid recevied (constant 2012 US$) of Czech Republic in 1992 to that in 1997?
Ensure brevity in your answer.  1.15. What is the ratio of the Aid recevied (constant 2012 US$) in Romania in 1992 to that in 1997?
Offer a very short reply. 1.17. What is the ratio of the Aid recevied (constant 2012 US$) of Middle income in 1992 to that in 1998?
Your answer should be very brief. 1.03. What is the ratio of the Aid recevied (constant 2012 US$) of Czech Republic in 1992 to that in 1998?
Provide a short and direct response. 0.29. What is the ratio of the Aid recevied (constant 2012 US$) in Romania in 1992 to that in 1998?
Provide a short and direct response. 0.69. What is the ratio of the Aid recevied (constant 2012 US$) of Middle income in 1993 to that in 1994?
Keep it short and to the point. 1.03. What is the ratio of the Aid recevied (constant 2012 US$) in Czech Republic in 1993 to that in 1994?
Ensure brevity in your answer.  0.68. What is the ratio of the Aid recevied (constant 2012 US$) of Romania in 1993 to that in 1994?
Keep it short and to the point. 1.15. What is the ratio of the Aid recevied (constant 2012 US$) in Middle income in 1993 to that in 1995?
Provide a succinct answer. 1.44. What is the ratio of the Aid recevied (constant 2012 US$) of Czech Republic in 1993 to that in 1995?
Ensure brevity in your answer.  0.8. What is the ratio of the Aid recevied (constant 2012 US$) of Romania in 1993 to that in 1995?
Make the answer very short. 0.66. What is the ratio of the Aid recevied (constant 2012 US$) in Middle income in 1993 to that in 1996?
Give a very brief answer. 0.95. What is the ratio of the Aid recevied (constant 2012 US$) of Czech Republic in 1993 to that in 1996?
Keep it short and to the point. 0.9. What is the ratio of the Aid recevied (constant 2012 US$) in Romania in 1993 to that in 1996?
Provide a short and direct response. 0.84. What is the ratio of the Aid recevied (constant 2012 US$) of Middle income in 1993 to that in 1997?
Provide a succinct answer. 1.07. What is the ratio of the Aid recevied (constant 2012 US$) of Czech Republic in 1993 to that in 1997?
Ensure brevity in your answer.  0.9. What is the ratio of the Aid recevied (constant 2012 US$) in Romania in 1993 to that in 1997?
Make the answer very short. 0.8. What is the ratio of the Aid recevied (constant 2012 US$) in Middle income in 1993 to that in 1998?
Ensure brevity in your answer.  0.73. What is the ratio of the Aid recevied (constant 2012 US$) of Czech Republic in 1993 to that in 1998?
Offer a terse response. 0.23. What is the ratio of the Aid recevied (constant 2012 US$) in Romania in 1993 to that in 1998?
Your answer should be very brief. 0.47. What is the ratio of the Aid recevied (constant 2012 US$) in Middle income in 1994 to that in 1995?
Your answer should be compact. 1.39. What is the ratio of the Aid recevied (constant 2012 US$) of Czech Republic in 1994 to that in 1995?
Your response must be concise. 1.17. What is the ratio of the Aid recevied (constant 2012 US$) of Romania in 1994 to that in 1995?
Your answer should be very brief. 0.57. What is the ratio of the Aid recevied (constant 2012 US$) in Middle income in 1994 to that in 1996?
Make the answer very short. 0.92. What is the ratio of the Aid recevied (constant 2012 US$) of Czech Republic in 1994 to that in 1996?
Ensure brevity in your answer.  1.32. What is the ratio of the Aid recevied (constant 2012 US$) in Romania in 1994 to that in 1996?
Ensure brevity in your answer.  0.73. What is the ratio of the Aid recevied (constant 2012 US$) of Middle income in 1994 to that in 1997?
Your answer should be very brief. 1.04. What is the ratio of the Aid recevied (constant 2012 US$) in Czech Republic in 1994 to that in 1997?
Offer a terse response. 1.32. What is the ratio of the Aid recevied (constant 2012 US$) of Romania in 1994 to that in 1997?
Make the answer very short. 0.69. What is the ratio of the Aid recevied (constant 2012 US$) of Middle income in 1994 to that in 1998?
Provide a short and direct response. 0.7. What is the ratio of the Aid recevied (constant 2012 US$) of Czech Republic in 1994 to that in 1998?
Offer a very short reply. 0.34. What is the ratio of the Aid recevied (constant 2012 US$) of Romania in 1994 to that in 1998?
Offer a very short reply. 0.41. What is the ratio of the Aid recevied (constant 2012 US$) in Middle income in 1995 to that in 1996?
Your answer should be compact. 0.66. What is the ratio of the Aid recevied (constant 2012 US$) of Czech Republic in 1995 to that in 1996?
Provide a succinct answer. 1.13. What is the ratio of the Aid recevied (constant 2012 US$) in Romania in 1995 to that in 1996?
Provide a short and direct response. 1.27. What is the ratio of the Aid recevied (constant 2012 US$) in Middle income in 1995 to that in 1997?
Your response must be concise. 0.75. What is the ratio of the Aid recevied (constant 2012 US$) of Czech Republic in 1995 to that in 1997?
Keep it short and to the point. 1.13. What is the ratio of the Aid recevied (constant 2012 US$) of Romania in 1995 to that in 1997?
Offer a terse response. 1.21. What is the ratio of the Aid recevied (constant 2012 US$) of Middle income in 1995 to that in 1998?
Your answer should be very brief. 0.51. What is the ratio of the Aid recevied (constant 2012 US$) of Czech Republic in 1995 to that in 1998?
Your response must be concise. 0.29. What is the ratio of the Aid recevied (constant 2012 US$) in Romania in 1995 to that in 1998?
Keep it short and to the point. 0.72. What is the ratio of the Aid recevied (constant 2012 US$) of Middle income in 1996 to that in 1997?
Make the answer very short. 1.12. What is the ratio of the Aid recevied (constant 2012 US$) in Czech Republic in 1996 to that in 1997?
Your answer should be compact. 1. What is the ratio of the Aid recevied (constant 2012 US$) of Romania in 1996 to that in 1997?
Offer a terse response. 0.95. What is the ratio of the Aid recevied (constant 2012 US$) in Middle income in 1996 to that in 1998?
Your response must be concise. 0.76. What is the ratio of the Aid recevied (constant 2012 US$) of Czech Republic in 1996 to that in 1998?
Make the answer very short. 0.25. What is the ratio of the Aid recevied (constant 2012 US$) of Romania in 1996 to that in 1998?
Your response must be concise. 0.56. What is the ratio of the Aid recevied (constant 2012 US$) in Middle income in 1997 to that in 1998?
Keep it short and to the point. 0.68. What is the ratio of the Aid recevied (constant 2012 US$) of Czech Republic in 1997 to that in 1998?
Your answer should be very brief. 0.25. What is the ratio of the Aid recevied (constant 2012 US$) in Romania in 1997 to that in 1998?
Your answer should be very brief. 0.59. What is the difference between the highest and the second highest Aid recevied (constant 2012 US$) of Middle income?
Offer a very short reply. 7.59e+08. What is the difference between the highest and the second highest Aid recevied (constant 2012 US$) of Czech Republic?
Your answer should be compact. 2.89e+08. What is the difference between the highest and the second highest Aid recevied (constant 2012 US$) in Romania?
Your response must be concise. 5.06e+07. What is the difference between the highest and the lowest Aid recevied (constant 2012 US$) of Middle income?
Provide a short and direct response. 1.77e+09. What is the difference between the highest and the lowest Aid recevied (constant 2012 US$) of Czech Republic?
Provide a succinct answer. 5.02e+08. What is the difference between the highest and the lowest Aid recevied (constant 2012 US$) in Romania?
Make the answer very short. 3.14e+08. 